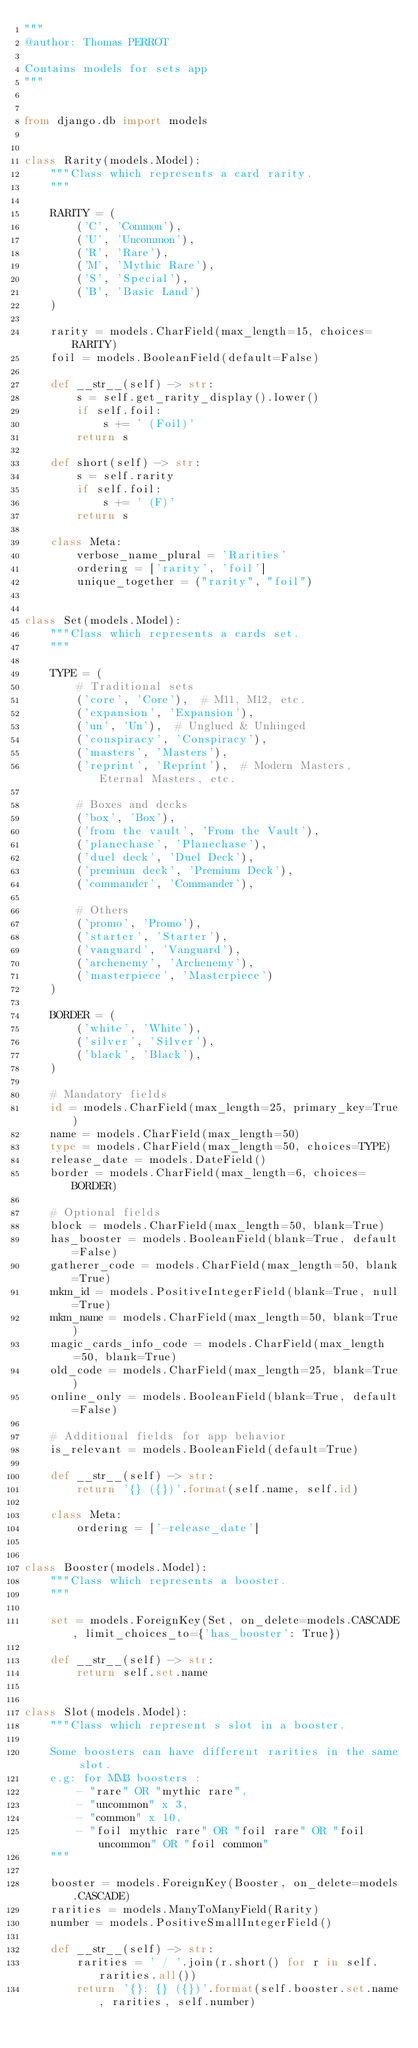<code> <loc_0><loc_0><loc_500><loc_500><_Python_>"""
@author: Thomas PERROT

Contains models for sets app
"""


from django.db import models


class Rarity(models.Model):
    """Class which represents a card rarity.
    """

    RARITY = (
        ('C', 'Common'),
        ('U', 'Uncommon'),
        ('R', 'Rare'),
        ('M', 'Mythic Rare'),
        ('S', 'Special'),
        ('B', 'Basic Land')
    )

    rarity = models.CharField(max_length=15, choices=RARITY)
    foil = models.BooleanField(default=False)

    def __str__(self) -> str:
        s = self.get_rarity_display().lower()
        if self.foil:
            s += ' (Foil)'
        return s

    def short(self) -> str:
        s = self.rarity
        if self.foil:
            s += ' (F)'
        return s

    class Meta:
        verbose_name_plural = 'Rarities'
        ordering = ['rarity', 'foil']
        unique_together = ("rarity", "foil")


class Set(models.Model):
    """Class which represents a cards set.
    """

    TYPE = (
        # Traditional sets
        ('core', 'Core'),  # M11, M12, etc.
        ('expansion', 'Expansion'),
        ('un', 'Un'),  # Unglued & Unhinged
        ('conspiracy', 'Conspiracy'),
        ('masters', 'Masters'),
        ('reprint', 'Reprint'),  # Modern Masters, Eternal Masters, etc.

        # Boxes and decks
        ('box', 'Box'),
        ('from the vault', 'From the Vault'),
        ('planechase', 'Planechase'),
        ('duel deck', 'Duel Deck'),
        ('premium deck', 'Premium Deck'),
        ('commander', 'Commander'),

        # Others
        ('promo', 'Promo'),
        ('starter', 'Starter'),
        ('vanguard', 'Vanguard'),
        ('archenemy', 'Archenemy'),
        ('masterpiece', 'Masterpiece')
    )

    BORDER = (
        ('white', 'White'),
        ('silver', 'Silver'),
        ('black', 'Black'),
    )

    # Mandatory fields
    id = models.CharField(max_length=25, primary_key=True)
    name = models.CharField(max_length=50)
    type = models.CharField(max_length=50, choices=TYPE)
    release_date = models.DateField()
    border = models.CharField(max_length=6, choices=BORDER)

    # Optional fields
    block = models.CharField(max_length=50, blank=True)
    has_booster = models.BooleanField(blank=True, default=False)
    gatherer_code = models.CharField(max_length=50, blank=True)
    mkm_id = models.PositiveIntegerField(blank=True, null=True)
    mkm_name = models.CharField(max_length=50, blank=True)
    magic_cards_info_code = models.CharField(max_length=50, blank=True)
    old_code = models.CharField(max_length=25, blank=True)
    online_only = models.BooleanField(blank=True, default=False)

    # Additional fields for app behavior
    is_relevant = models.BooleanField(default=True)

    def __str__(self) -> str:
        return '{} ({})'.format(self.name, self.id)

    class Meta:
        ordering = ['-release_date']


class Booster(models.Model):
    """Class which represents a booster.
    """

    set = models.ForeignKey(Set, on_delete=models.CASCADE, limit_choices_to={'has_booster': True})

    def __str__(self) -> str:
        return self.set.name


class Slot(models.Model):
    """Class which represent s slot in a booster.

    Some boosters can have different rarities in the same slot.
    e.g: for MM3 boosters :
        - "rare" OR "mythic rare",
        - "uncommon" x 3,
        - "common" x 10,
        - "foil mythic rare" OR "foil rare" OR "foil uncommon" OR "foil common"
    """

    booster = models.ForeignKey(Booster, on_delete=models.CASCADE)
    rarities = models.ManyToManyField(Rarity)
    number = models.PositiveSmallIntegerField()

    def __str__(self) -> str:
        rarities = ' / '.join(r.short() for r in self.rarities.all())
        return '{}: {} ({})'.format(self.booster.set.name, rarities, self.number)
</code> 